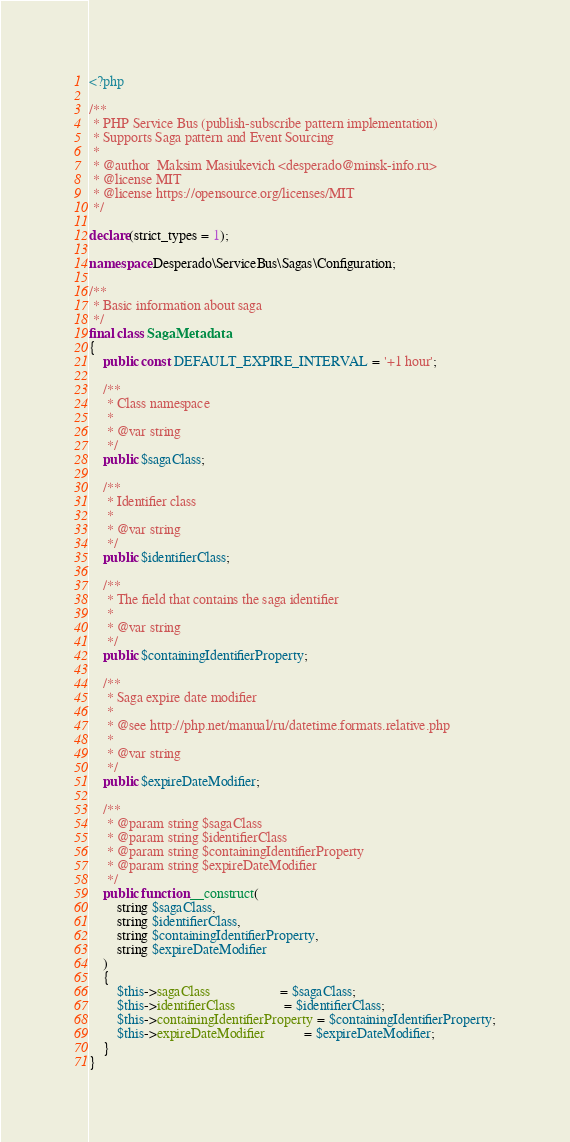Convert code to text. <code><loc_0><loc_0><loc_500><loc_500><_PHP_><?php

/**
 * PHP Service Bus (publish-subscribe pattern implementation)
 * Supports Saga pattern and Event Sourcing
 *
 * @author  Maksim Masiukevich <desperado@minsk-info.ru>
 * @license MIT
 * @license https://opensource.org/licenses/MIT
 */

declare(strict_types = 1);

namespace Desperado\ServiceBus\Sagas\Configuration;

/**
 * Basic information about saga
 */
final class SagaMetadata
{
    public const DEFAULT_EXPIRE_INTERVAL = '+1 hour';

    /**
     * Class namespace
     *
     * @var string
     */
    public $sagaClass;

    /**
     * Identifier class
     *
     * @var string
     */
    public $identifierClass;

    /**
     * The field that contains the saga identifier
     *
     * @var string
     */
    public $containingIdentifierProperty;

    /**
     * Saga expire date modifier
     *
     * @see http://php.net/manual/ru/datetime.formats.relative.php
     *
     * @var string
     */
    public $expireDateModifier;

    /**
     * @param string $sagaClass
     * @param string $identifierClass
     * @param string $containingIdentifierProperty
     * @param string $expireDateModifier
     */
    public function __construct(
        string $sagaClass,
        string $identifierClass,
        string $containingIdentifierProperty,
        string $expireDateModifier
    )
    {
        $this->sagaClass                    = $sagaClass;
        $this->identifierClass              = $identifierClass;
        $this->containingIdentifierProperty = $containingIdentifierProperty;
        $this->expireDateModifier           = $expireDateModifier;
    }
}
</code> 